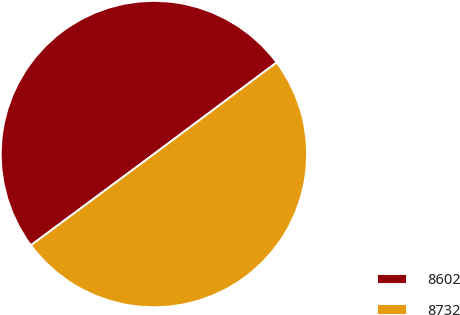Convert chart. <chart><loc_0><loc_0><loc_500><loc_500><pie_chart><fcel>8602<fcel>8732<nl><fcel>49.95%<fcel>50.05%<nl></chart> 